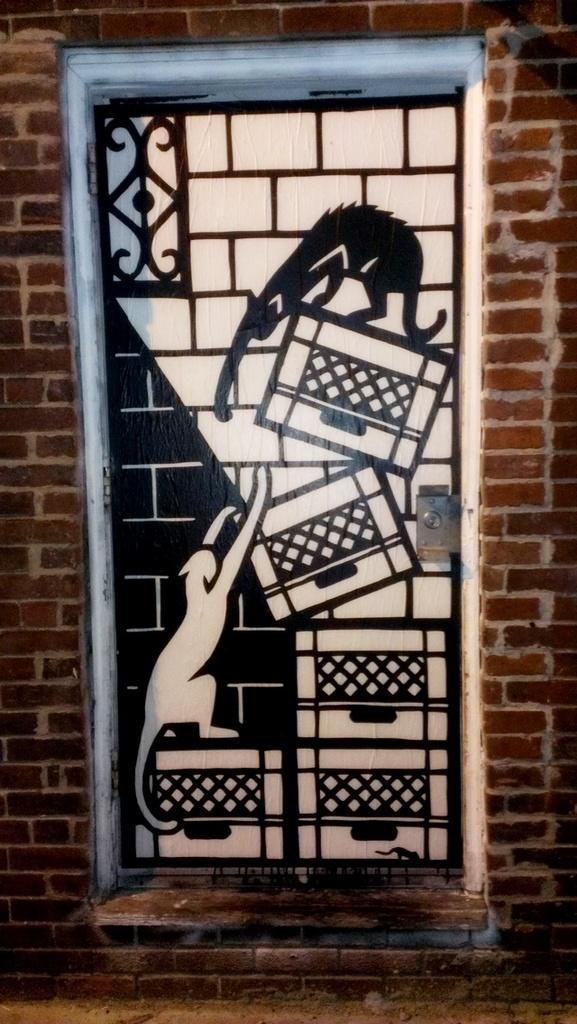Could you give a brief overview of what you see in this image? As we can see in the image there is a brick wall and door. 